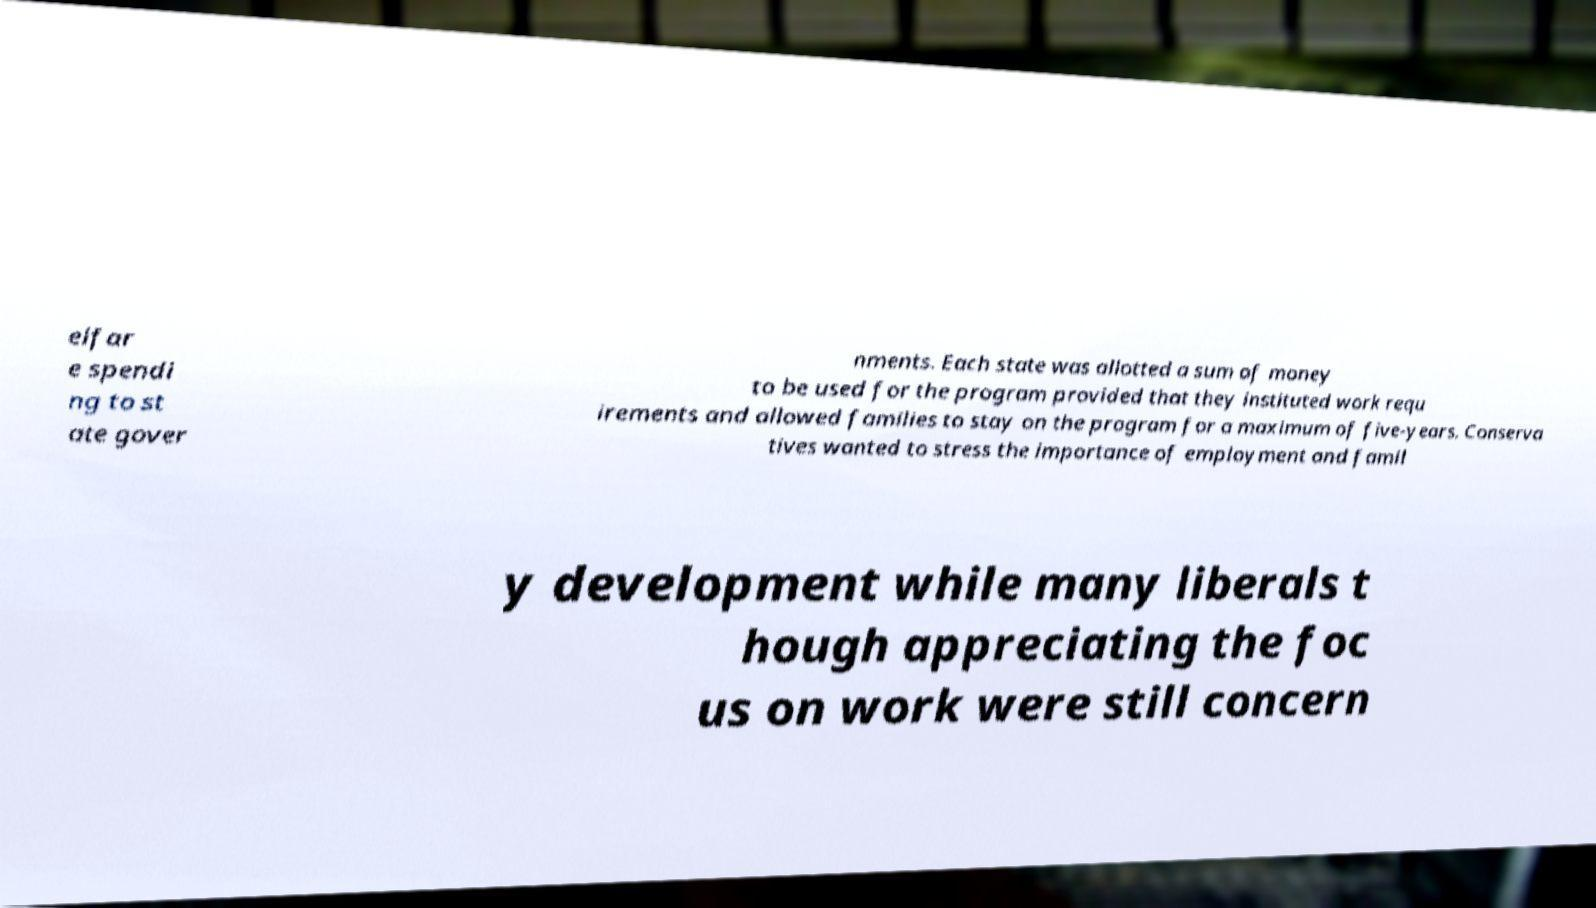There's text embedded in this image that I need extracted. Can you transcribe it verbatim? elfar e spendi ng to st ate gover nments. Each state was allotted a sum of money to be used for the program provided that they instituted work requ irements and allowed families to stay on the program for a maximum of five-years. Conserva tives wanted to stress the importance of employment and famil y development while many liberals t hough appreciating the foc us on work were still concern 